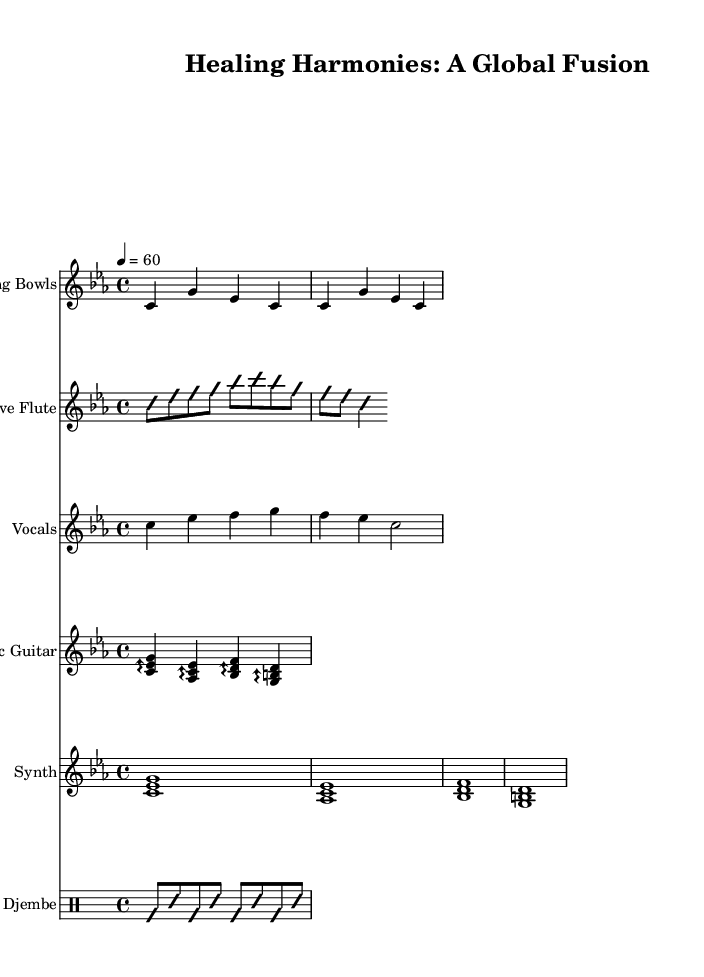What is the key signature of this music? The key signature is specified at the beginning of the global section and indicates C minor, which has three flats (B flat, E flat, and A flat).
Answer: C minor What is the time signature of this music? The time signature is located next to the key signature in the global section, showing that this piece is in a 4/4 time signature, meaning there are four beats per measure.
Answer: 4/4 What is the tempo marking for this music? The tempo marking is indicated in the global section and denotes quarter note equals sixty beats per minute, which establishes the pace of the piece.
Answer: 60 How many different instruments are used in this piece? By examining the score layout, there are five distinct instruments indicated: Singing Bowls, Native Flute, Vocals, Electric Guitar, Synth, and Djembe, totaling six instruments.
Answer: 6 What type of voicing is employed in the vocals section? The vocals section shows a single melodic line without harmonization or multiple voices, which is indicative of solo singing.
Answer: Solo Which instrument plays the rhythmic accompaniment? The djembe section provides the rhythmic foundation of the piece, utilizing a pattern typical of percussion instruments that emphasize the beat.
Answer: Djembe 